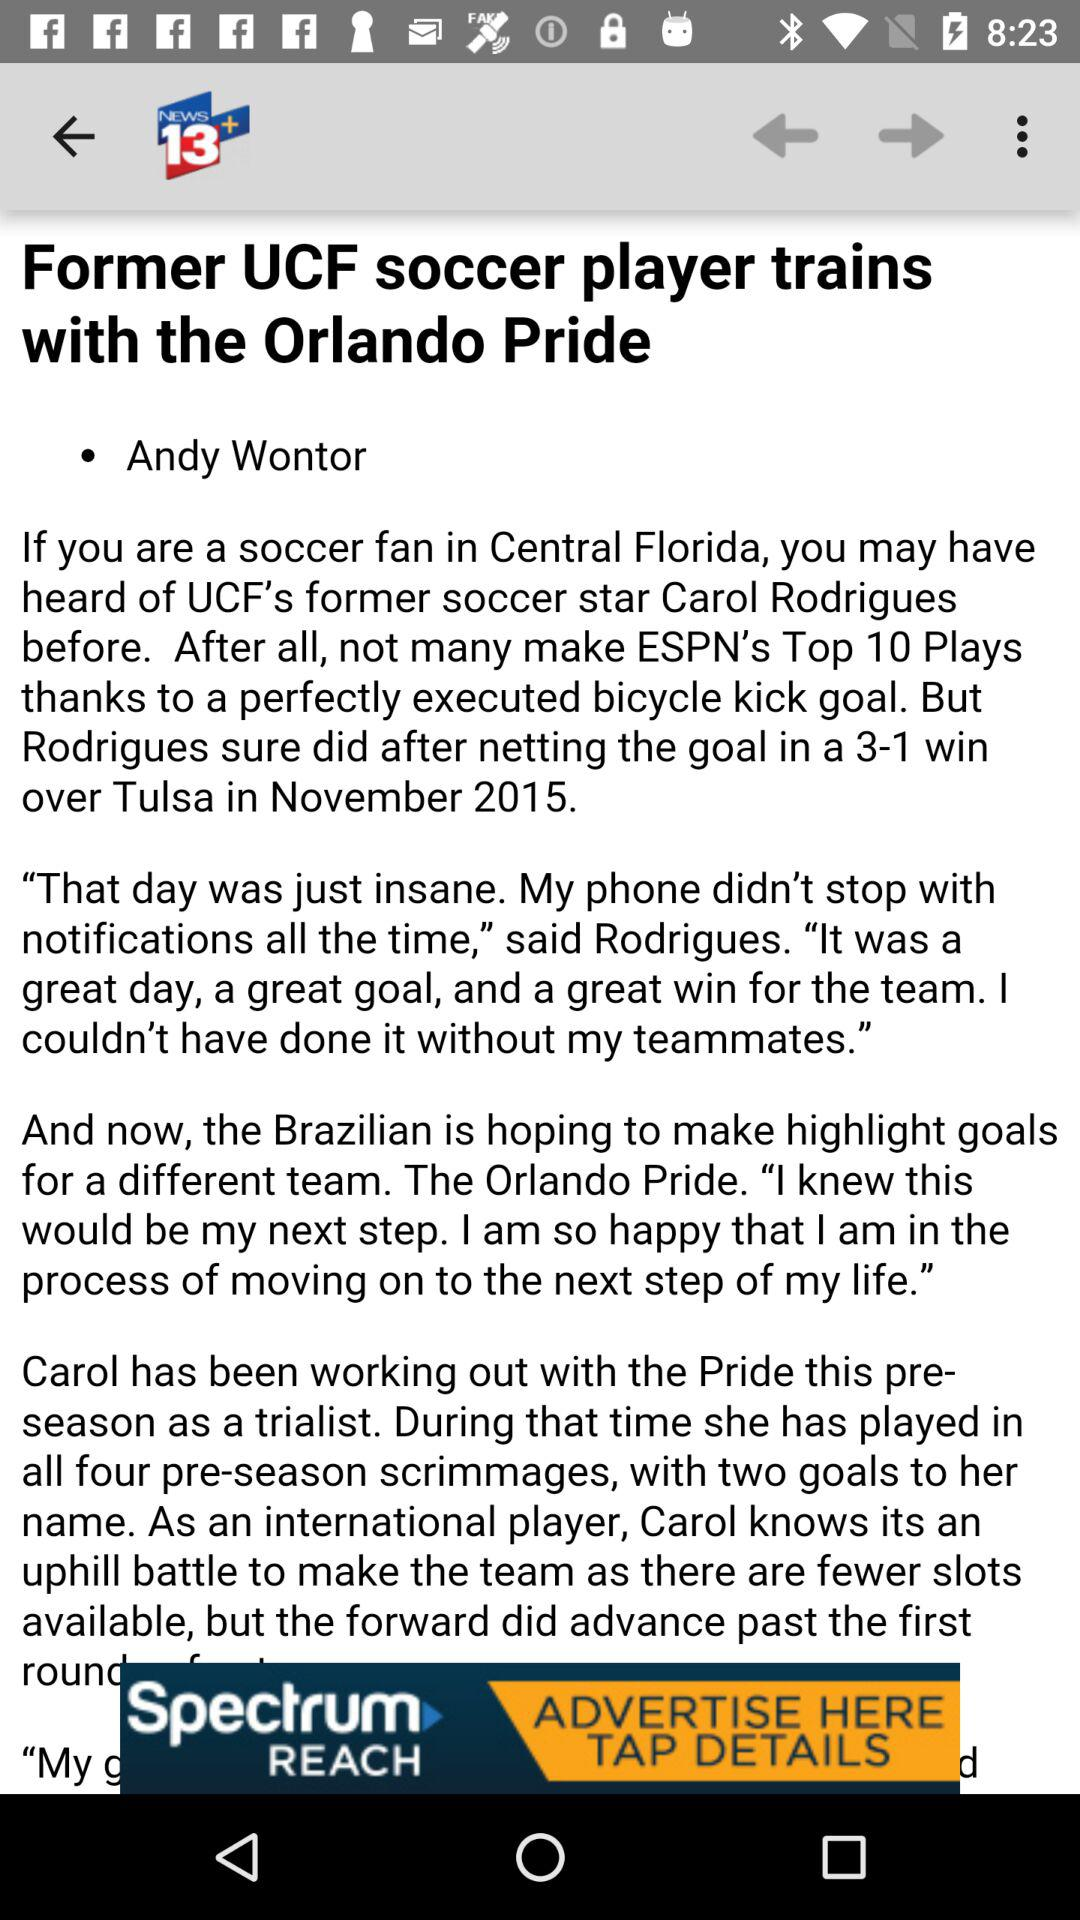Who's the author of the article? The author of the article is Andy Wontor. 